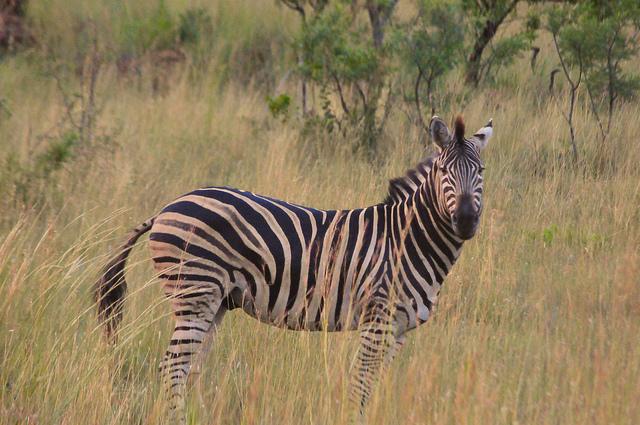How many zebras do you see?
Quick response, please. 1. Is the zebra in a zoo?
Be succinct. No. Is the zebra pregnant?
Be succinct. No. Are there trees in the background?
Answer briefly. Yes. What animal is looking at the camera?
Give a very brief answer. Zebra. Is this zebra looking at the camera?
Quick response, please. Yes. What color is the zebra?
Concise answer only. Black and white. Is this Zebra looking right or left?
Answer briefly. Right. Is this an adult?
Answer briefly. Yes. 